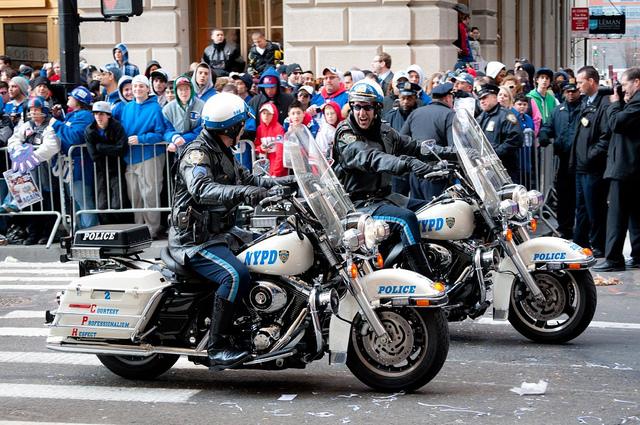What are some of the spectators doing with their hands?
Short answer required. Nothing. How many motorcycles are there?
Write a very short answer. 2. What police department are the officers from?
Write a very short answer. Nypd. Why is there a crowd of people?
Keep it brief. Parade. 